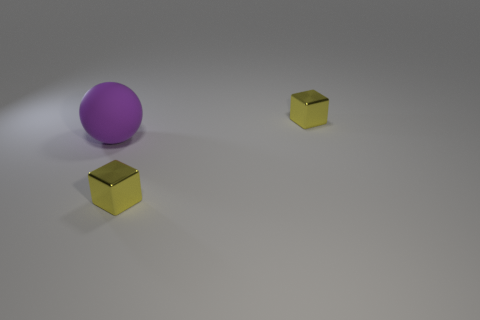Is there anything else that has the same material as the purple ball?
Your answer should be very brief. No. Is the number of purple matte things less than the number of small yellow metallic cubes?
Your response must be concise. Yes. Does the metal thing that is in front of the purple object have the same color as the big ball?
Make the answer very short. No. How many rubber spheres are in front of the large thing?
Give a very brief answer. 0. Are there more tiny blue rubber cylinders than small yellow shiny objects?
Your response must be concise. No. Are there any big rubber cubes?
Ensure brevity in your answer.  No. The small yellow shiny object that is behind the block to the left of the thing behind the purple object is what shape?
Provide a short and direct response. Cube. What number of other yellow things are the same shape as the large thing?
Make the answer very short. 0. There is a small block that is behind the matte ball; is its color the same as the cube in front of the purple rubber sphere?
Make the answer very short. Yes. Are there fewer big objects that are left of the rubber ball than tiny blocks?
Your response must be concise. Yes. 